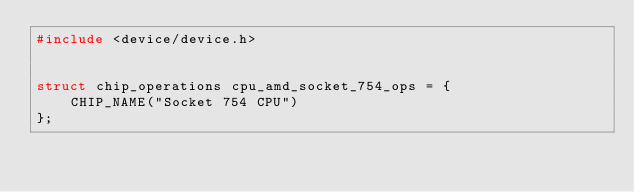Convert code to text. <code><loc_0><loc_0><loc_500><loc_500><_C_>#include <device/device.h>


struct chip_operations cpu_amd_socket_754_ops = {
	CHIP_NAME("Socket 754 CPU")
};
</code> 